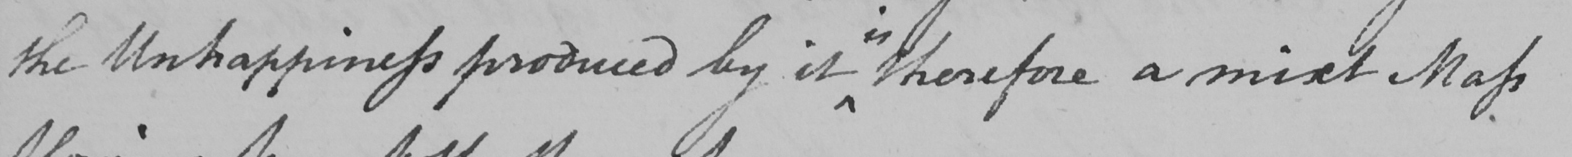Can you tell me what this handwritten text says? the Unhappiness produced by it therefore a mixt Mass 